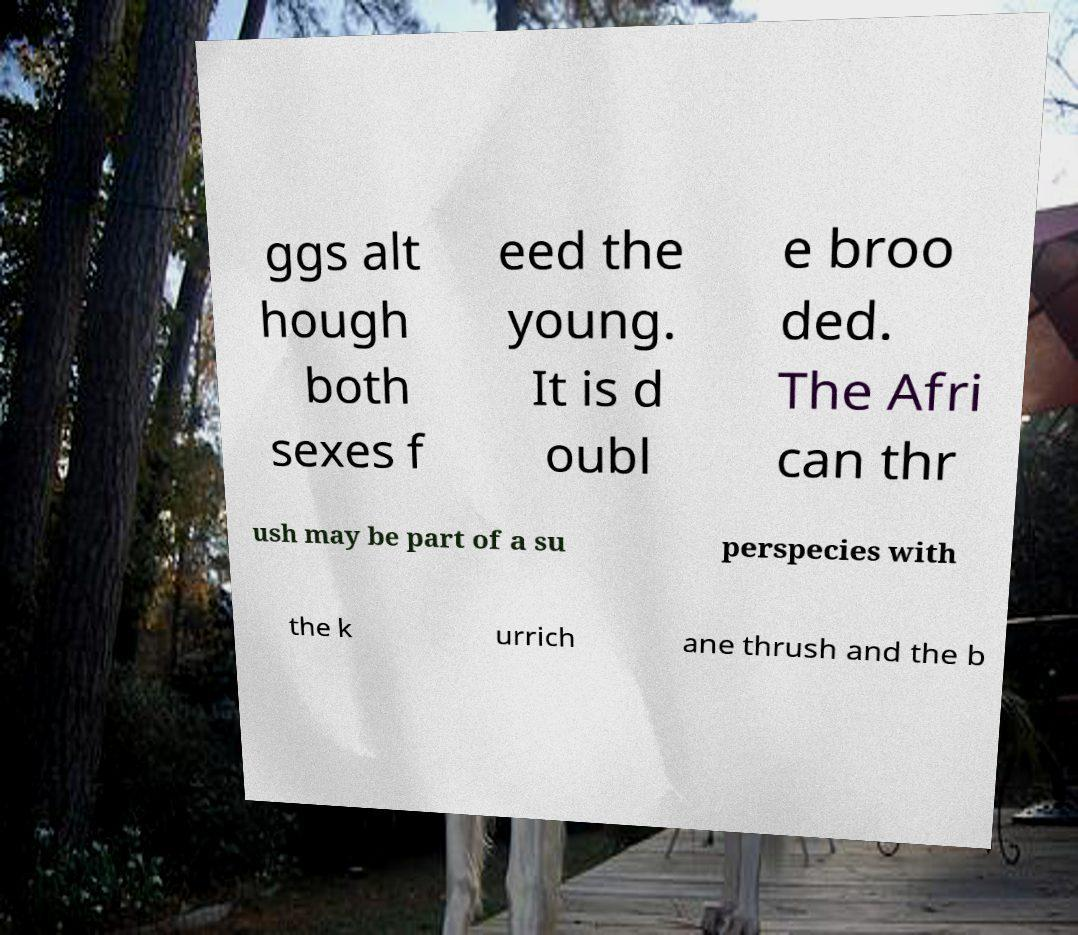Can you read and provide the text displayed in the image?This photo seems to have some interesting text. Can you extract and type it out for me? ggs alt hough both sexes f eed the young. It is d oubl e broo ded. The Afri can thr ush may be part of a su perspecies with the k urrich ane thrush and the b 